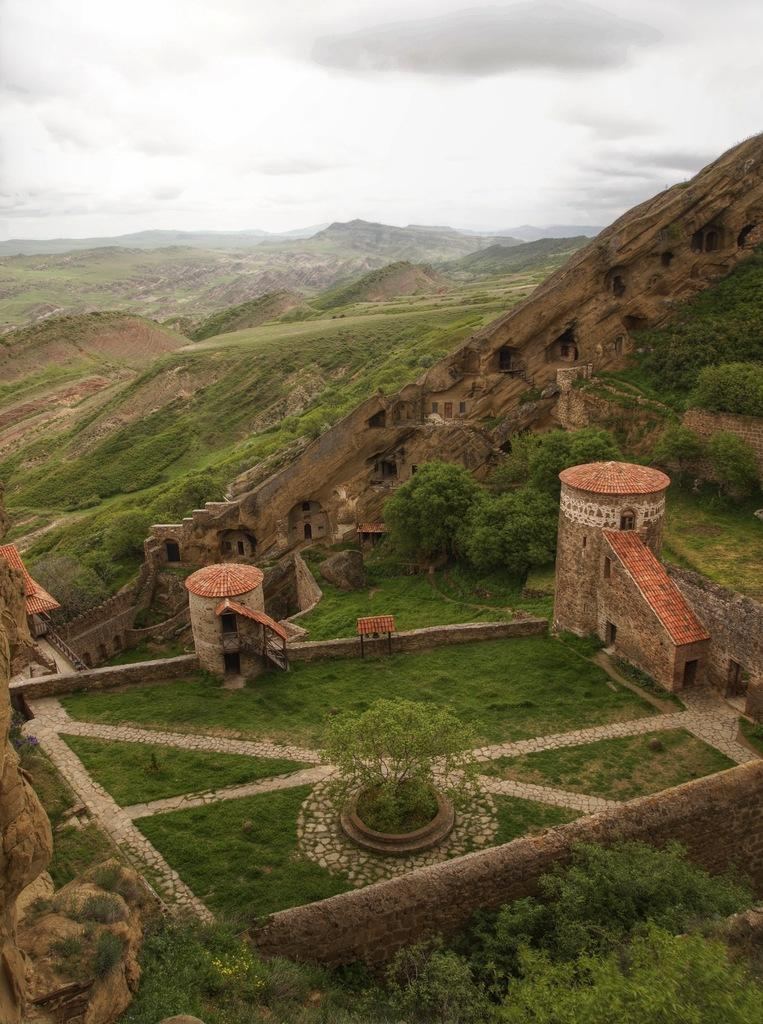What type of structures can be seen in the image? There are buildings in the image. What type of vegetation is present in the image? There are trees and grass in the image. What can be seen in the background of the image? Hills and clouds are visible in the background of the image. How many credit cards are visible in the image? There are no credit cards present in the image. What type of stick can be seen in the image? There is no stick present in the image. 